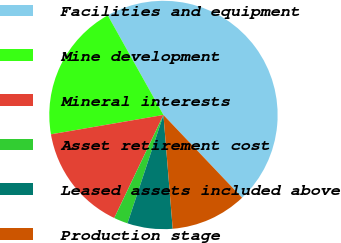Convert chart to OTSL. <chart><loc_0><loc_0><loc_500><loc_500><pie_chart><fcel>Facilities and equipment<fcel>Mine development<fcel>Mineral interests<fcel>Asset retirement cost<fcel>Leased assets included above<fcel>Production stage<nl><fcel>46.02%<fcel>19.6%<fcel>15.2%<fcel>1.99%<fcel>6.39%<fcel>10.8%<nl></chart> 